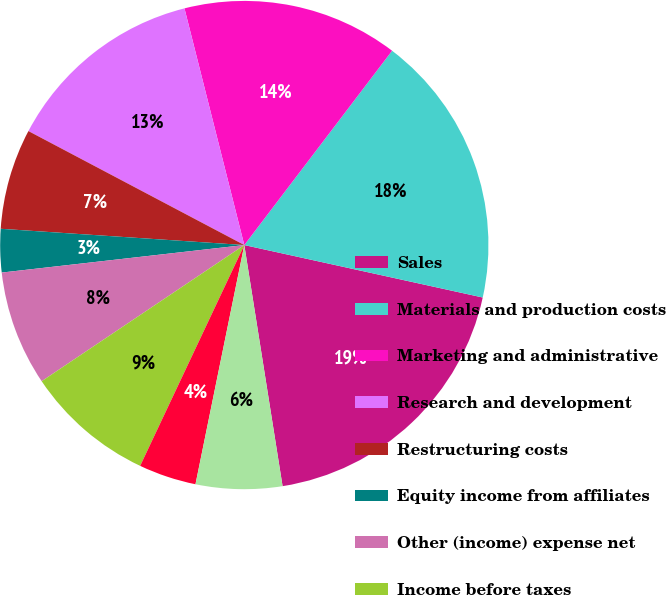Convert chart to OTSL. <chart><loc_0><loc_0><loc_500><loc_500><pie_chart><fcel>Sales<fcel>Materials and production costs<fcel>Marketing and administrative<fcel>Research and development<fcel>Restructuring costs<fcel>Equity income from affiliates<fcel>Other (income) expense net<fcel>Income before taxes<fcel>Taxes on income<fcel>Net income<nl><fcel>19.05%<fcel>18.1%<fcel>14.29%<fcel>13.33%<fcel>6.67%<fcel>2.86%<fcel>7.62%<fcel>8.57%<fcel>3.81%<fcel>5.71%<nl></chart> 